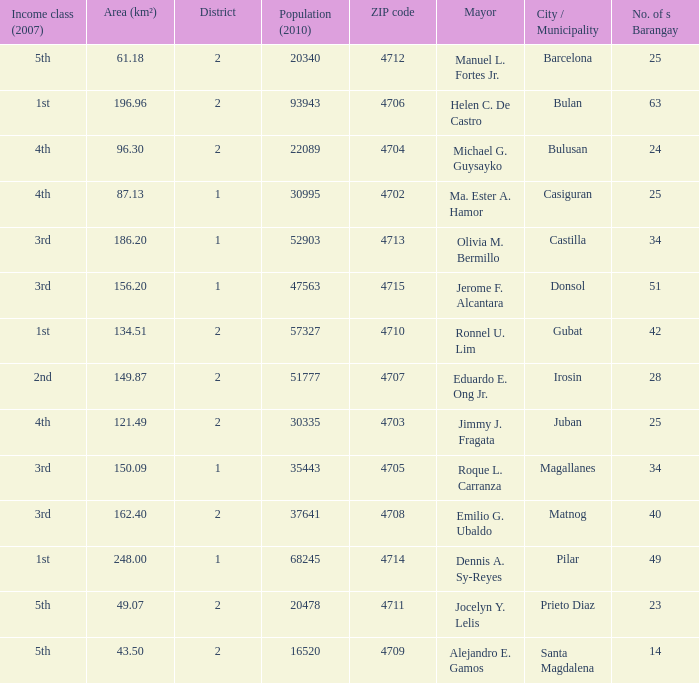What are all the metropolis / municipality where mayor is helen c. De castro Bulan. 